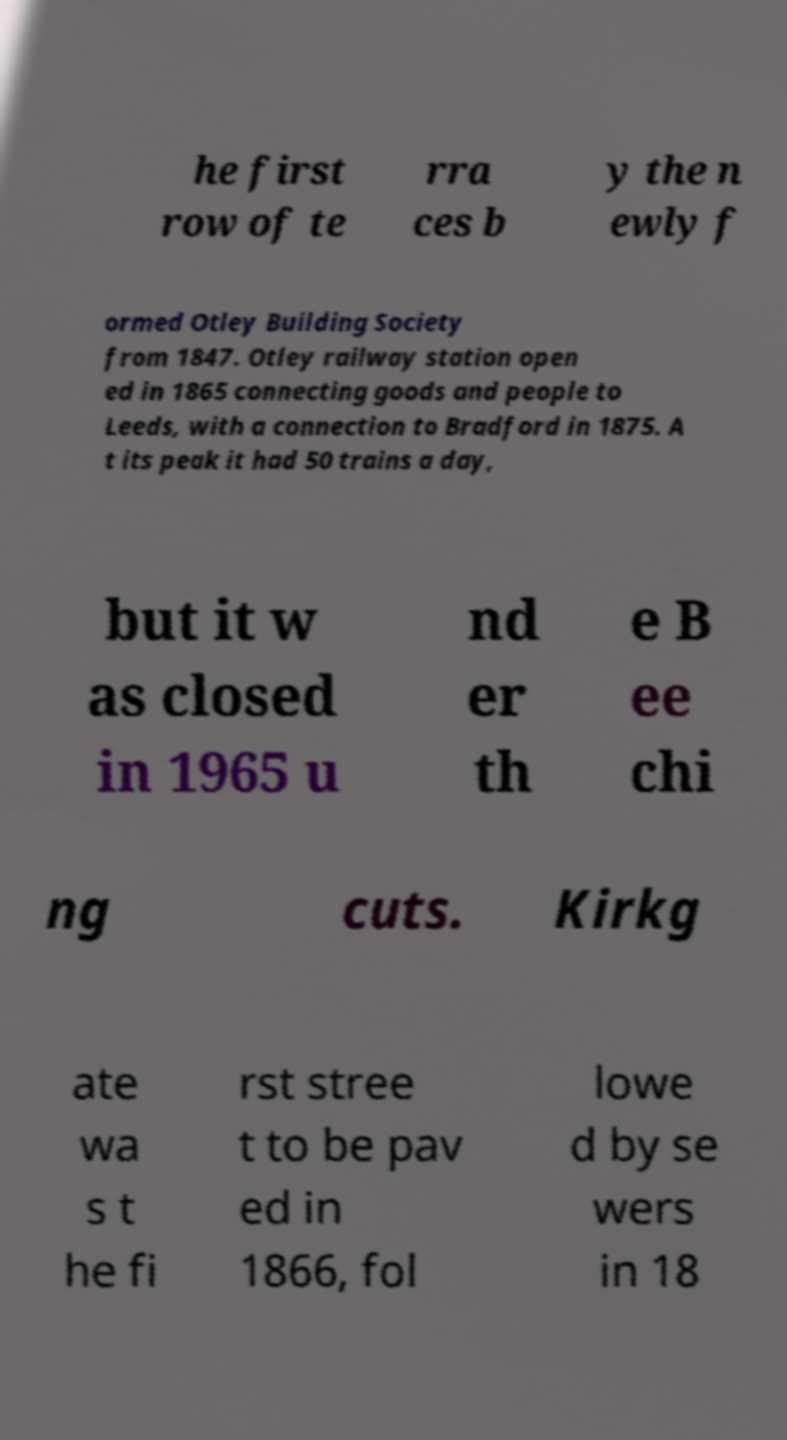Please identify and transcribe the text found in this image. he first row of te rra ces b y the n ewly f ormed Otley Building Society from 1847. Otley railway station open ed in 1865 connecting goods and people to Leeds, with a connection to Bradford in 1875. A t its peak it had 50 trains a day, but it w as closed in 1965 u nd er th e B ee chi ng cuts. Kirkg ate wa s t he fi rst stree t to be pav ed in 1866, fol lowe d by se wers in 18 